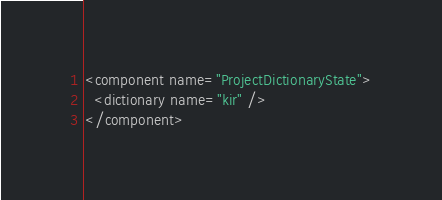<code> <loc_0><loc_0><loc_500><loc_500><_XML_><component name="ProjectDictionaryState">
  <dictionary name="kir" />
</component></code> 